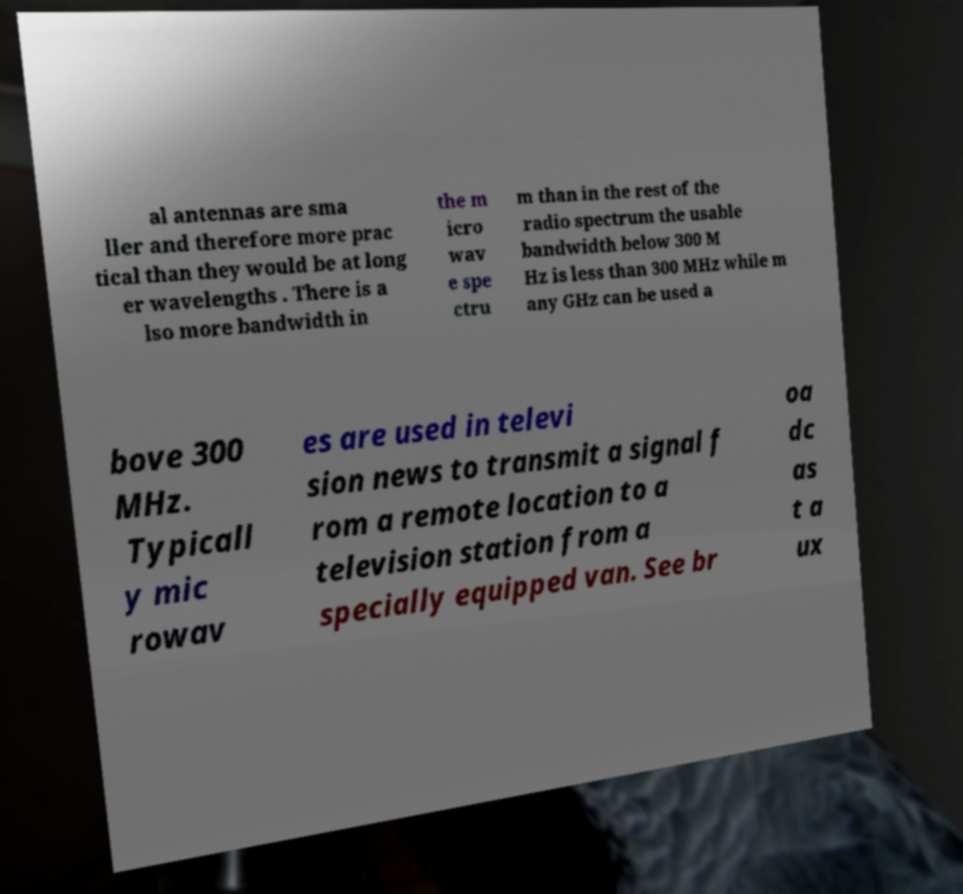Please identify and transcribe the text found in this image. al antennas are sma ller and therefore more prac tical than they would be at long er wavelengths . There is a lso more bandwidth in the m icro wav e spe ctru m than in the rest of the radio spectrum the usable bandwidth below 300 M Hz is less than 300 MHz while m any GHz can be used a bove 300 MHz. Typicall y mic rowav es are used in televi sion news to transmit a signal f rom a remote location to a television station from a specially equipped van. See br oa dc as t a ux 